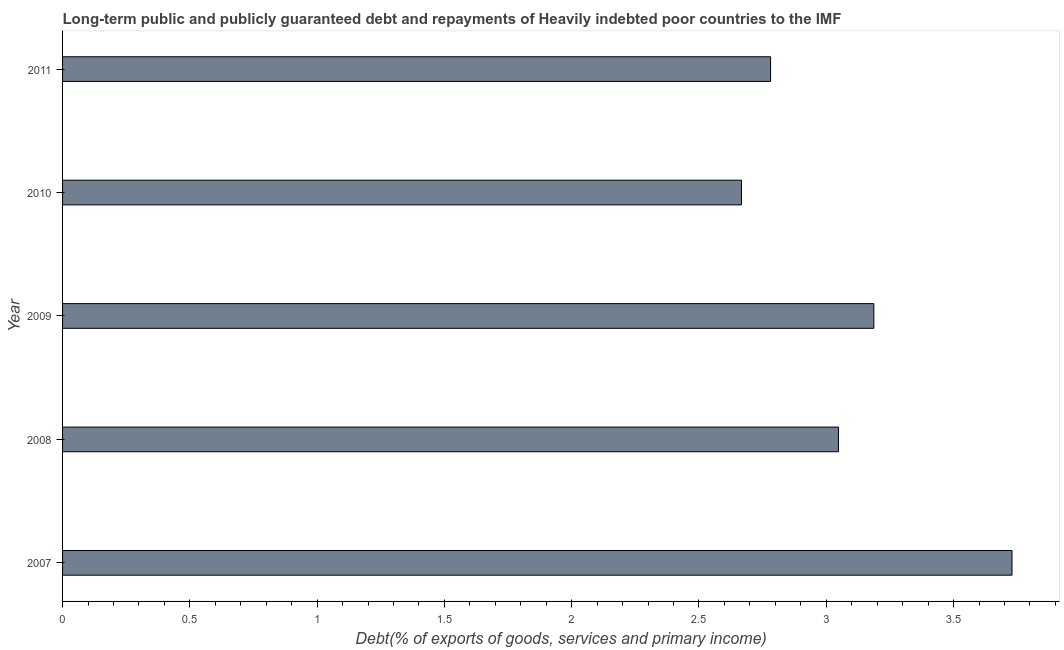Does the graph contain any zero values?
Make the answer very short. No. What is the title of the graph?
Make the answer very short. Long-term public and publicly guaranteed debt and repayments of Heavily indebted poor countries to the IMF. What is the label or title of the X-axis?
Ensure brevity in your answer.  Debt(% of exports of goods, services and primary income). What is the label or title of the Y-axis?
Ensure brevity in your answer.  Year. What is the debt service in 2010?
Provide a short and direct response. 2.67. Across all years, what is the maximum debt service?
Your answer should be compact. 3.73. Across all years, what is the minimum debt service?
Make the answer very short. 2.67. What is the sum of the debt service?
Give a very brief answer. 15.41. What is the difference between the debt service in 2007 and 2009?
Your answer should be compact. 0.54. What is the average debt service per year?
Ensure brevity in your answer.  3.08. What is the median debt service?
Give a very brief answer. 3.05. In how many years, is the debt service greater than 3.2 %?
Keep it short and to the point. 1. Do a majority of the years between 2008 and 2007 (inclusive) have debt service greater than 1.6 %?
Make the answer very short. No. What is the ratio of the debt service in 2009 to that in 2010?
Offer a terse response. 1.2. What is the difference between the highest and the second highest debt service?
Provide a short and direct response. 0.54. Is the sum of the debt service in 2010 and 2011 greater than the maximum debt service across all years?
Provide a short and direct response. Yes. What is the difference between the highest and the lowest debt service?
Offer a very short reply. 1.06. In how many years, is the debt service greater than the average debt service taken over all years?
Make the answer very short. 2. How many bars are there?
Make the answer very short. 5. Are the values on the major ticks of X-axis written in scientific E-notation?
Keep it short and to the point. No. What is the Debt(% of exports of goods, services and primary income) in 2007?
Offer a terse response. 3.73. What is the Debt(% of exports of goods, services and primary income) in 2008?
Make the answer very short. 3.05. What is the Debt(% of exports of goods, services and primary income) in 2009?
Offer a terse response. 3.19. What is the Debt(% of exports of goods, services and primary income) in 2010?
Make the answer very short. 2.67. What is the Debt(% of exports of goods, services and primary income) in 2011?
Your response must be concise. 2.78. What is the difference between the Debt(% of exports of goods, services and primary income) in 2007 and 2008?
Provide a succinct answer. 0.68. What is the difference between the Debt(% of exports of goods, services and primary income) in 2007 and 2009?
Offer a terse response. 0.54. What is the difference between the Debt(% of exports of goods, services and primary income) in 2007 and 2010?
Ensure brevity in your answer.  1.06. What is the difference between the Debt(% of exports of goods, services and primary income) in 2007 and 2011?
Ensure brevity in your answer.  0.95. What is the difference between the Debt(% of exports of goods, services and primary income) in 2008 and 2009?
Make the answer very short. -0.14. What is the difference between the Debt(% of exports of goods, services and primary income) in 2008 and 2010?
Keep it short and to the point. 0.38. What is the difference between the Debt(% of exports of goods, services and primary income) in 2008 and 2011?
Ensure brevity in your answer.  0.27. What is the difference between the Debt(% of exports of goods, services and primary income) in 2009 and 2010?
Provide a short and direct response. 0.52. What is the difference between the Debt(% of exports of goods, services and primary income) in 2009 and 2011?
Keep it short and to the point. 0.41. What is the difference between the Debt(% of exports of goods, services and primary income) in 2010 and 2011?
Keep it short and to the point. -0.11. What is the ratio of the Debt(% of exports of goods, services and primary income) in 2007 to that in 2008?
Your response must be concise. 1.22. What is the ratio of the Debt(% of exports of goods, services and primary income) in 2007 to that in 2009?
Offer a very short reply. 1.17. What is the ratio of the Debt(% of exports of goods, services and primary income) in 2007 to that in 2010?
Provide a succinct answer. 1.4. What is the ratio of the Debt(% of exports of goods, services and primary income) in 2007 to that in 2011?
Offer a terse response. 1.34. What is the ratio of the Debt(% of exports of goods, services and primary income) in 2008 to that in 2009?
Your response must be concise. 0.96. What is the ratio of the Debt(% of exports of goods, services and primary income) in 2008 to that in 2010?
Make the answer very short. 1.14. What is the ratio of the Debt(% of exports of goods, services and primary income) in 2008 to that in 2011?
Provide a succinct answer. 1.1. What is the ratio of the Debt(% of exports of goods, services and primary income) in 2009 to that in 2010?
Ensure brevity in your answer.  1.2. What is the ratio of the Debt(% of exports of goods, services and primary income) in 2009 to that in 2011?
Provide a succinct answer. 1.15. What is the ratio of the Debt(% of exports of goods, services and primary income) in 2010 to that in 2011?
Make the answer very short. 0.96. 